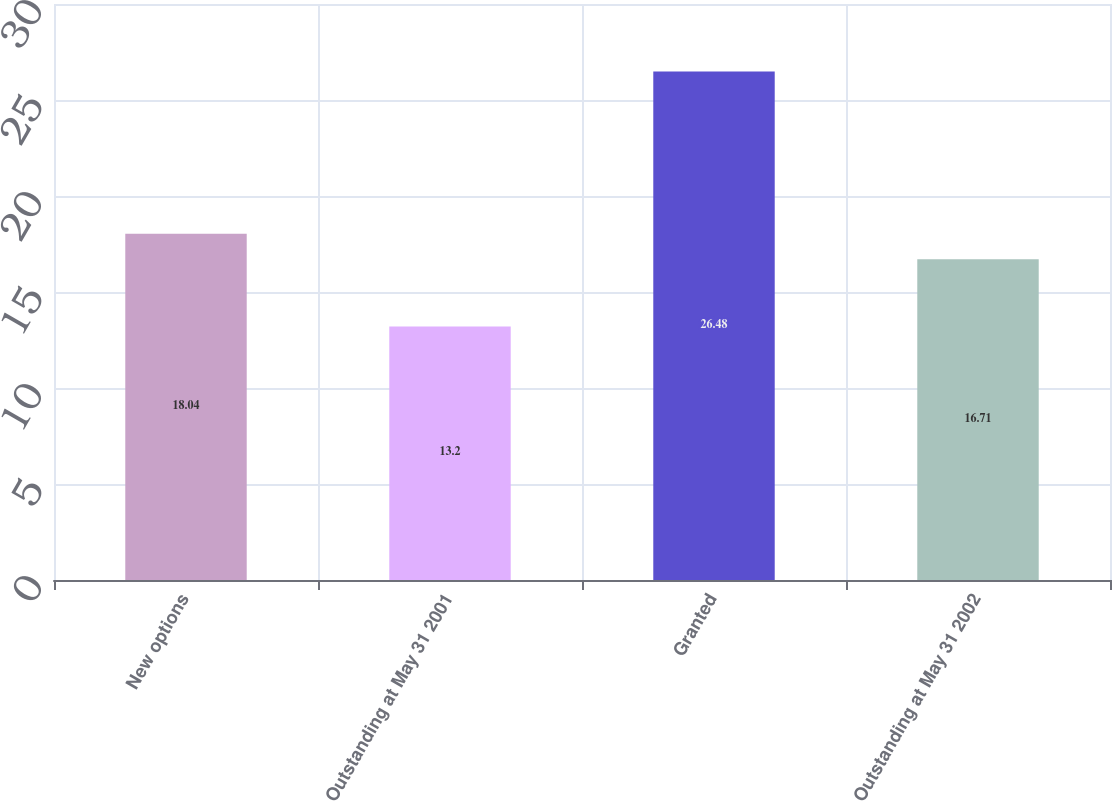<chart> <loc_0><loc_0><loc_500><loc_500><bar_chart><fcel>New options<fcel>Outstanding at May 31 2001<fcel>Granted<fcel>Outstanding at May 31 2002<nl><fcel>18.04<fcel>13.2<fcel>26.48<fcel>16.71<nl></chart> 